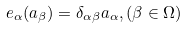<formula> <loc_0><loc_0><loc_500><loc_500>e _ { \alpha } ( a _ { \beta } ) = \delta _ { \alpha \beta } a _ { \alpha } , ( \beta \in \Omega )</formula> 